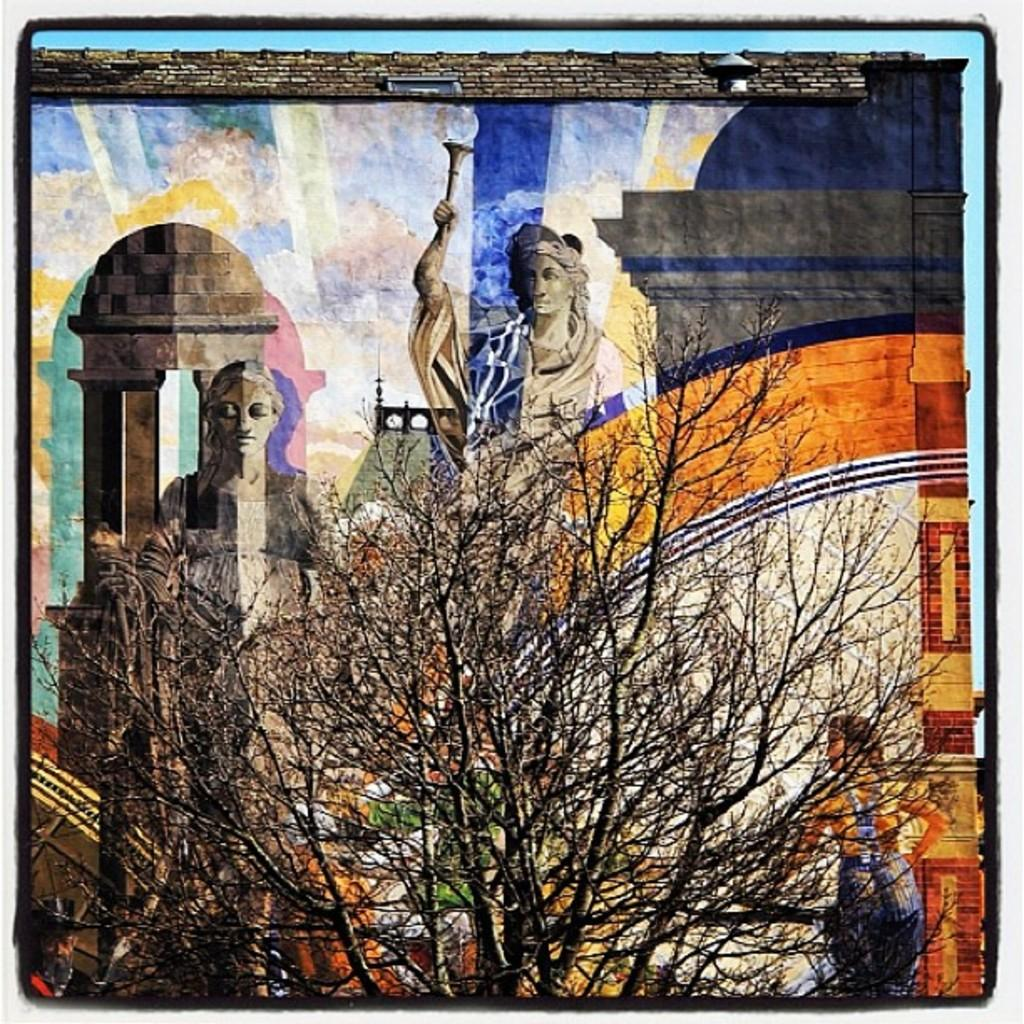What type of subjects are depicted in the painting? The painting contains person's statues, trees, and a person. What architectural feature can be seen in the painting? The painting contains an arch. What type of bait is being used by the person in the painting? There is no bait present in the painting; it features person's statues, trees, a person, and an arch. What emotion does the person in the painting seem to be experiencing? The painting does not convey any specific emotions, such as regret, as it is a still image. 